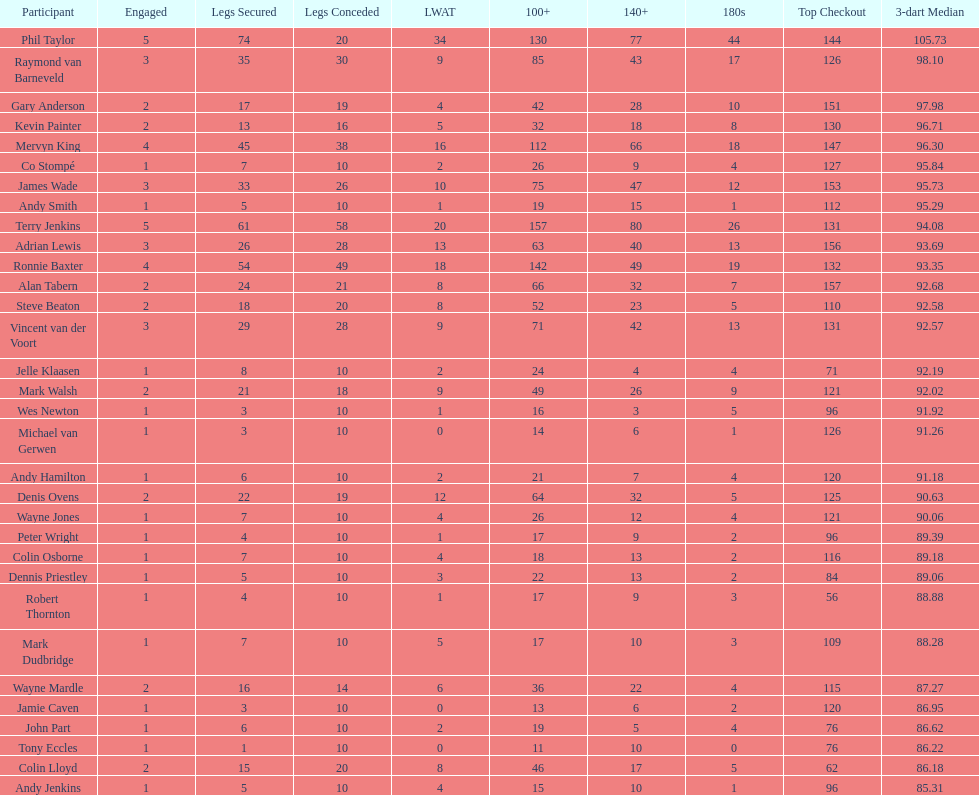Who won the highest number of legs in the 2009 world matchplay? Phil Taylor. 